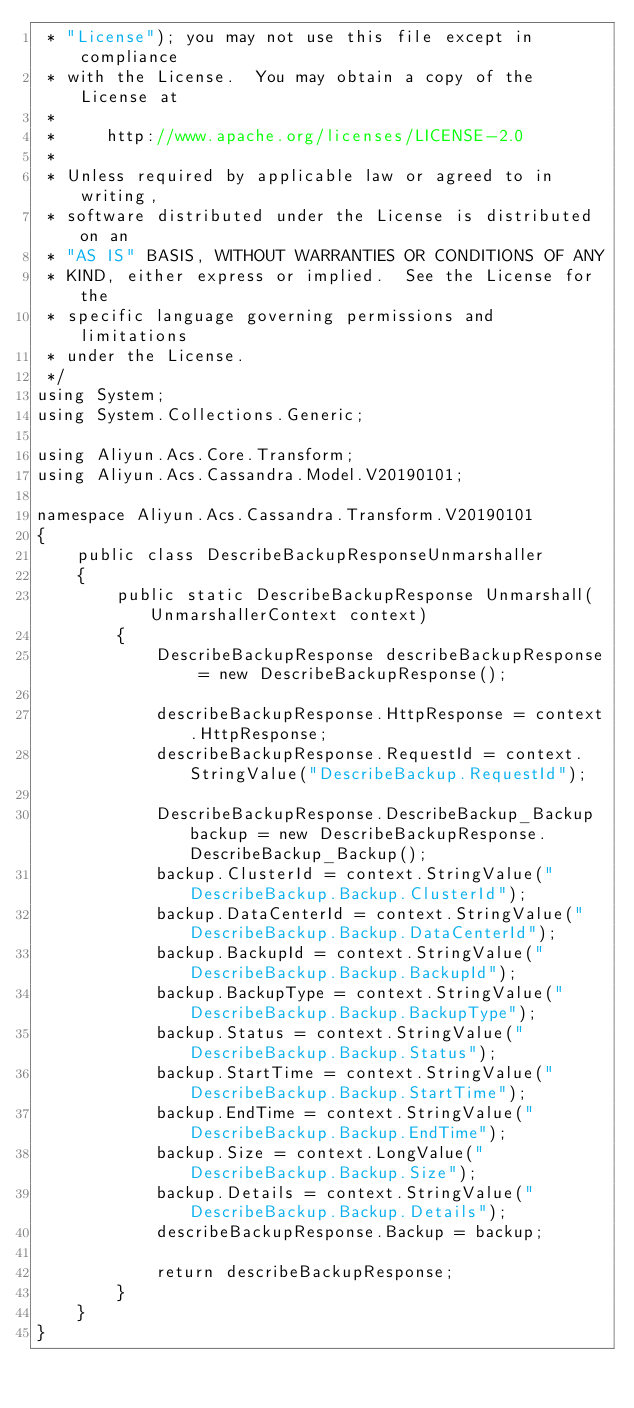<code> <loc_0><loc_0><loc_500><loc_500><_C#_> * "License"); you may not use this file except in compliance
 * with the License.  You may obtain a copy of the License at
 *
 *     http://www.apache.org/licenses/LICENSE-2.0
 *
 * Unless required by applicable law or agreed to in writing,
 * software distributed under the License is distributed on an
 * "AS IS" BASIS, WITHOUT WARRANTIES OR CONDITIONS OF ANY
 * KIND, either express or implied.  See the License for the
 * specific language governing permissions and limitations
 * under the License.
 */
using System;
using System.Collections.Generic;

using Aliyun.Acs.Core.Transform;
using Aliyun.Acs.Cassandra.Model.V20190101;

namespace Aliyun.Acs.Cassandra.Transform.V20190101
{
    public class DescribeBackupResponseUnmarshaller
    {
        public static DescribeBackupResponse Unmarshall(UnmarshallerContext context)
        {
			DescribeBackupResponse describeBackupResponse = new DescribeBackupResponse();

			describeBackupResponse.HttpResponse = context.HttpResponse;
			describeBackupResponse.RequestId = context.StringValue("DescribeBackup.RequestId");

			DescribeBackupResponse.DescribeBackup_Backup backup = new DescribeBackupResponse.DescribeBackup_Backup();
			backup.ClusterId = context.StringValue("DescribeBackup.Backup.ClusterId");
			backup.DataCenterId = context.StringValue("DescribeBackup.Backup.DataCenterId");
			backup.BackupId = context.StringValue("DescribeBackup.Backup.BackupId");
			backup.BackupType = context.StringValue("DescribeBackup.Backup.BackupType");
			backup.Status = context.StringValue("DescribeBackup.Backup.Status");
			backup.StartTime = context.StringValue("DescribeBackup.Backup.StartTime");
			backup.EndTime = context.StringValue("DescribeBackup.Backup.EndTime");
			backup.Size = context.LongValue("DescribeBackup.Backup.Size");
			backup.Details = context.StringValue("DescribeBackup.Backup.Details");
			describeBackupResponse.Backup = backup;
        
			return describeBackupResponse;
        }
    }
}
</code> 